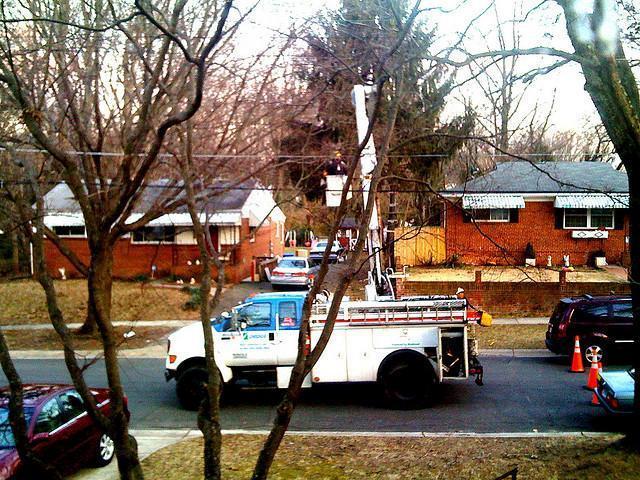How many cars are in the picture?
Give a very brief answer. 2. 